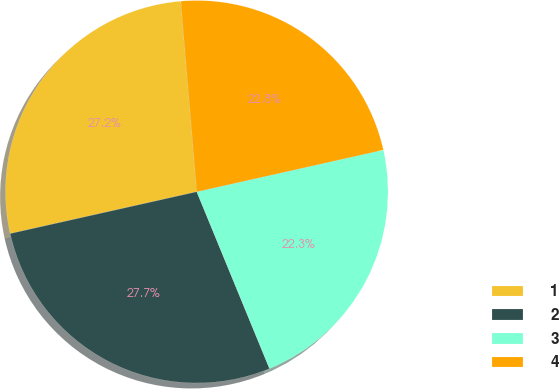Convert chart. <chart><loc_0><loc_0><loc_500><loc_500><pie_chart><fcel>1<fcel>2<fcel>3<fcel>4<nl><fcel>27.18%<fcel>27.7%<fcel>22.3%<fcel>22.82%<nl></chart> 